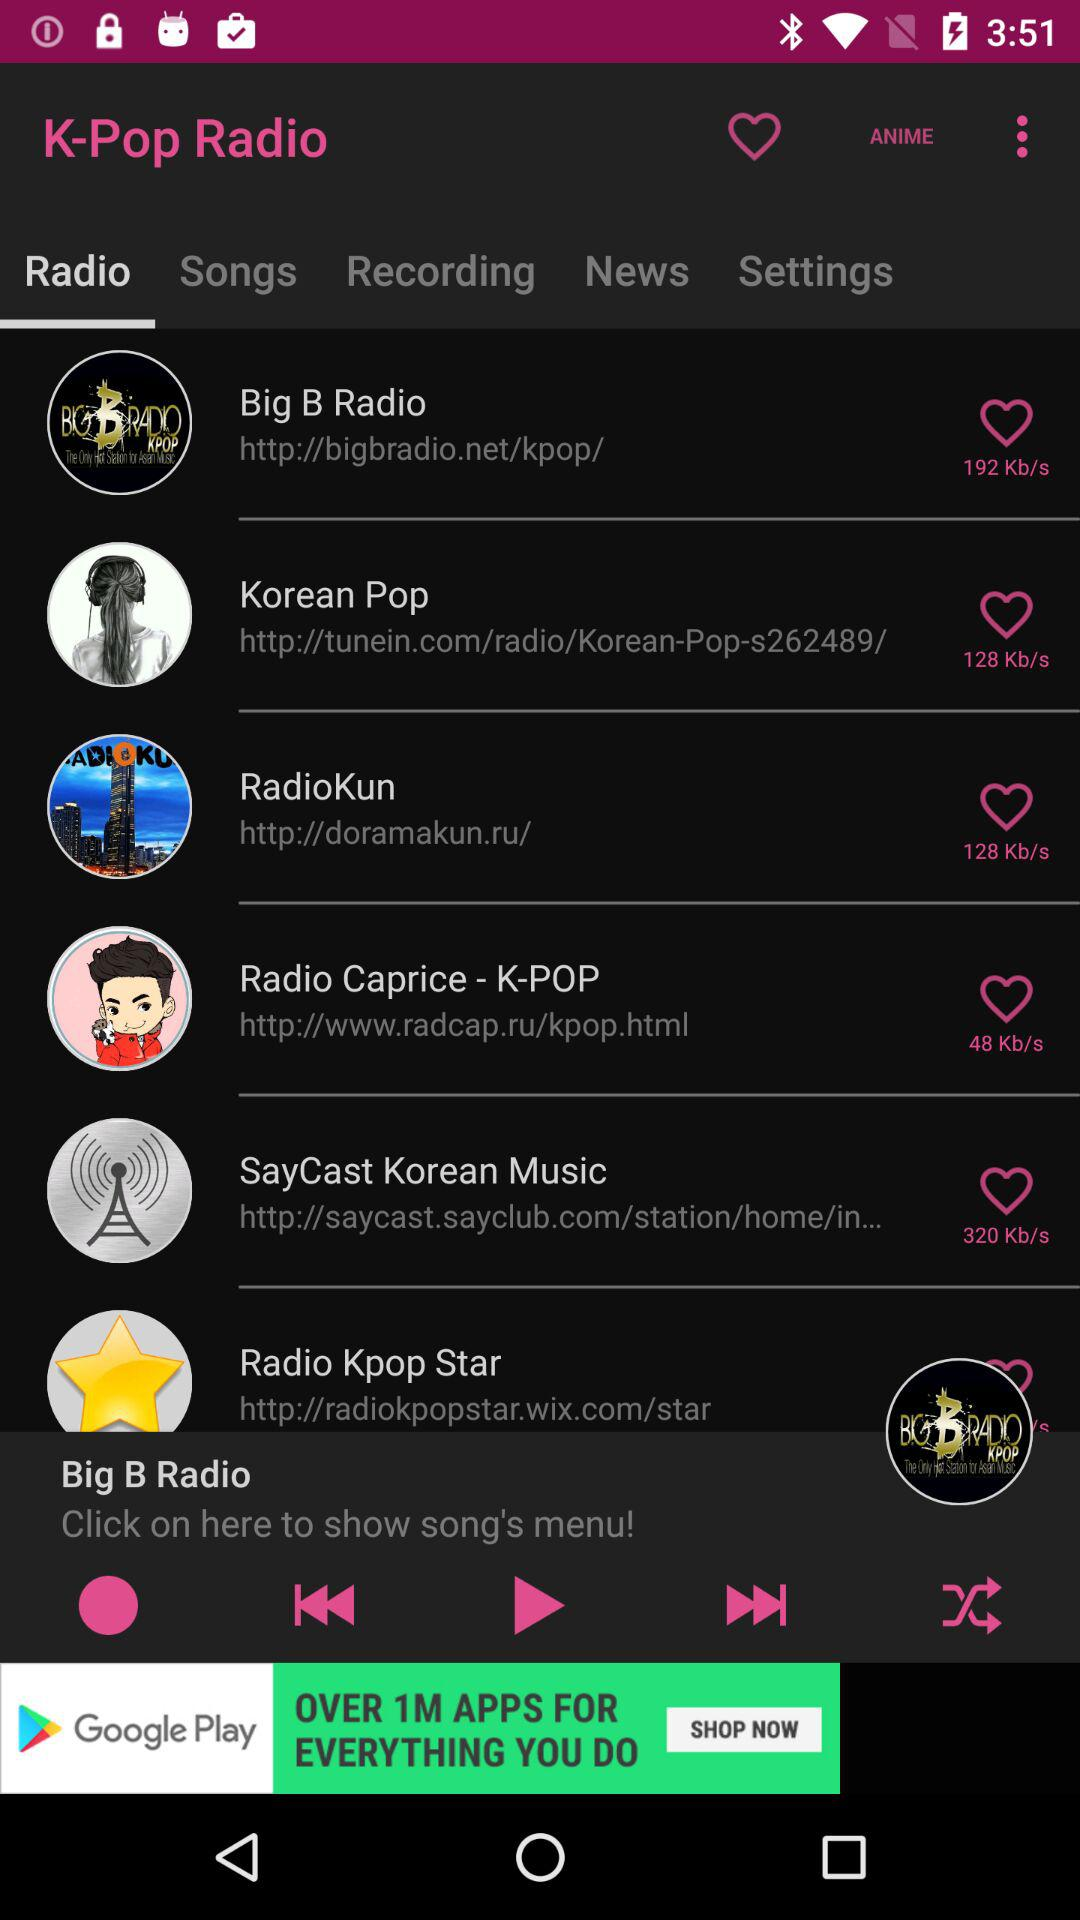What is the bitrate for "RadioKun"? The bitrate for "RadioKun" is 128 kb/s. 